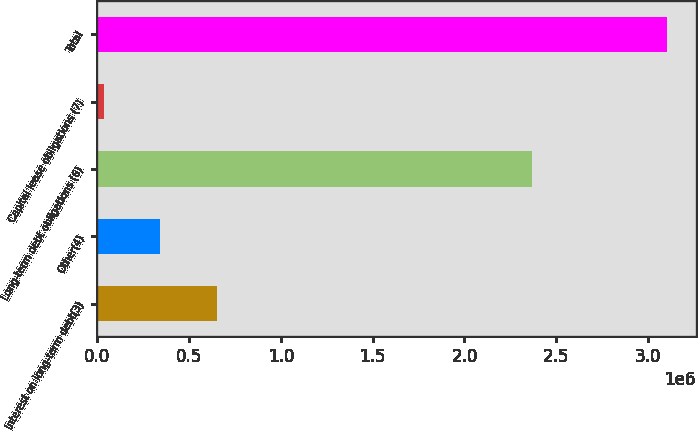Convert chart to OTSL. <chart><loc_0><loc_0><loc_500><loc_500><bar_chart><fcel>Interest on long-term debt(3)<fcel>Other(4)<fcel>Long-term debt obligations (6)<fcel>Capital lease obligations (7)<fcel>Total<nl><fcel>649576<fcel>342621<fcel>2.3665e+06<fcel>35666<fcel>3.10521e+06<nl></chart> 